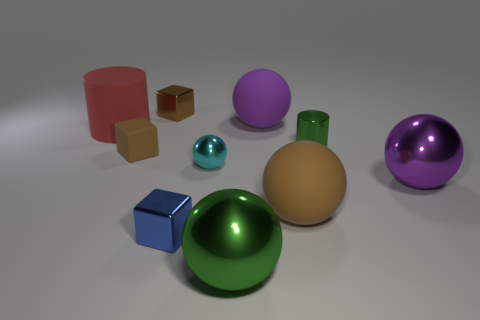Subtract 2 balls. How many balls are left? 3 Subtract all green spheres. How many spheres are left? 4 Subtract all small spheres. How many spheres are left? 4 Subtract all gray spheres. Subtract all cyan cubes. How many spheres are left? 5 Subtract all blocks. How many objects are left? 7 Subtract 0 yellow cylinders. How many objects are left? 10 Subtract all tiny brown metallic blocks. Subtract all metallic balls. How many objects are left? 6 Add 6 matte cubes. How many matte cubes are left? 7 Add 4 big gray metal spheres. How many big gray metal spheres exist? 4 